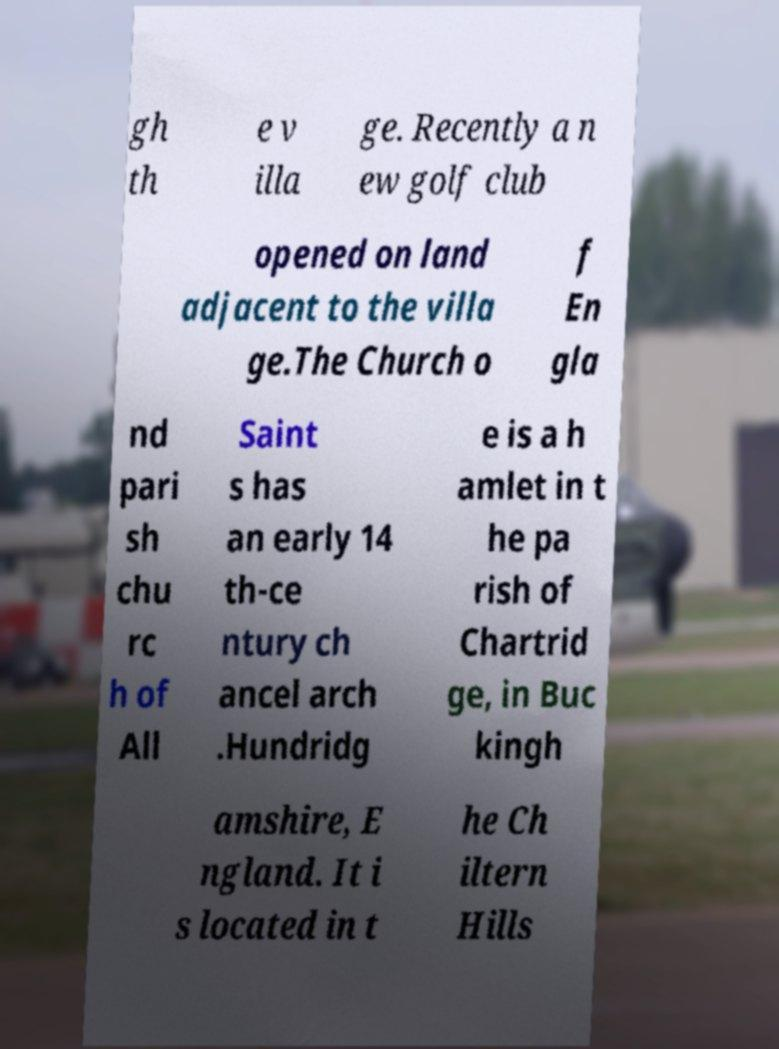I need the written content from this picture converted into text. Can you do that? gh th e v illa ge. Recently a n ew golf club opened on land adjacent to the villa ge.The Church o f En gla nd pari sh chu rc h of All Saint s has an early 14 th-ce ntury ch ancel arch .Hundridg e is a h amlet in t he pa rish of Chartrid ge, in Buc kingh amshire, E ngland. It i s located in t he Ch iltern Hills 